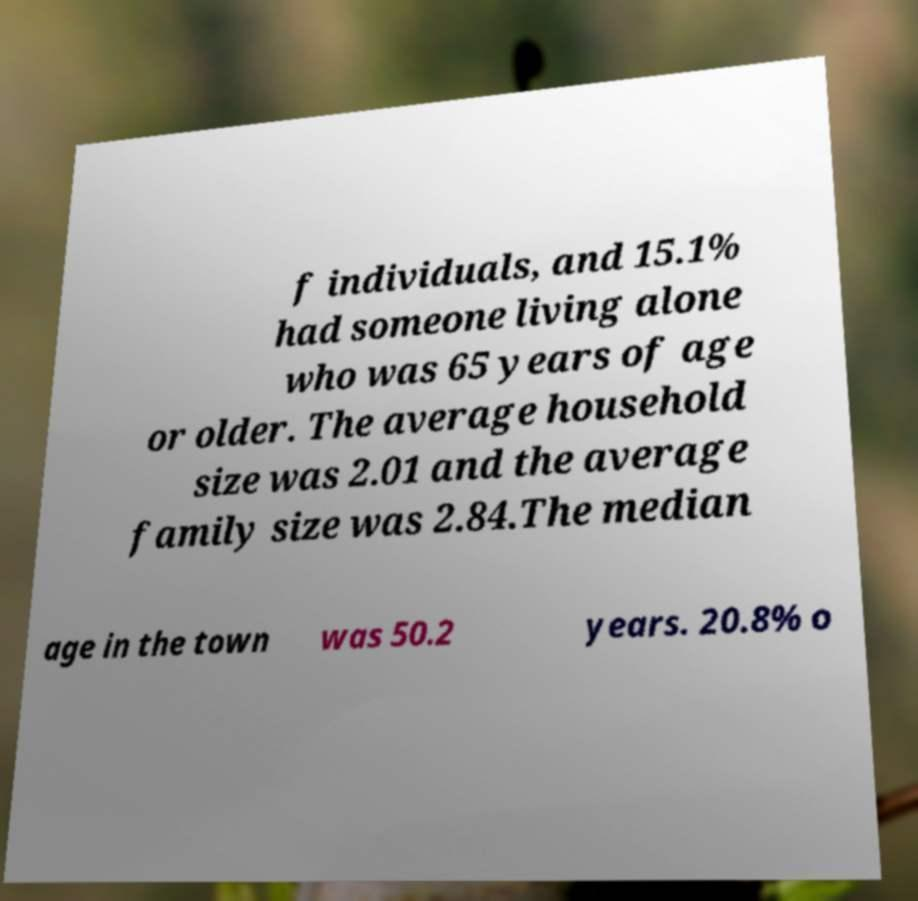For documentation purposes, I need the text within this image transcribed. Could you provide that? f individuals, and 15.1% had someone living alone who was 65 years of age or older. The average household size was 2.01 and the average family size was 2.84.The median age in the town was 50.2 years. 20.8% o 